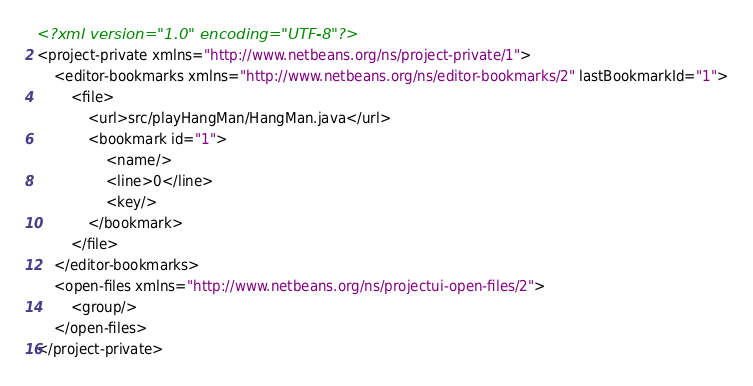<code> <loc_0><loc_0><loc_500><loc_500><_XML_><?xml version="1.0" encoding="UTF-8"?>
<project-private xmlns="http://www.netbeans.org/ns/project-private/1">
    <editor-bookmarks xmlns="http://www.netbeans.org/ns/editor-bookmarks/2" lastBookmarkId="1">
        <file>
            <url>src/playHangMan/HangMan.java</url>
            <bookmark id="1">
                <name/>
                <line>0</line>
                <key/>
            </bookmark>
        </file>
    </editor-bookmarks>
    <open-files xmlns="http://www.netbeans.org/ns/projectui-open-files/2">
        <group/>
    </open-files>
</project-private>
</code> 